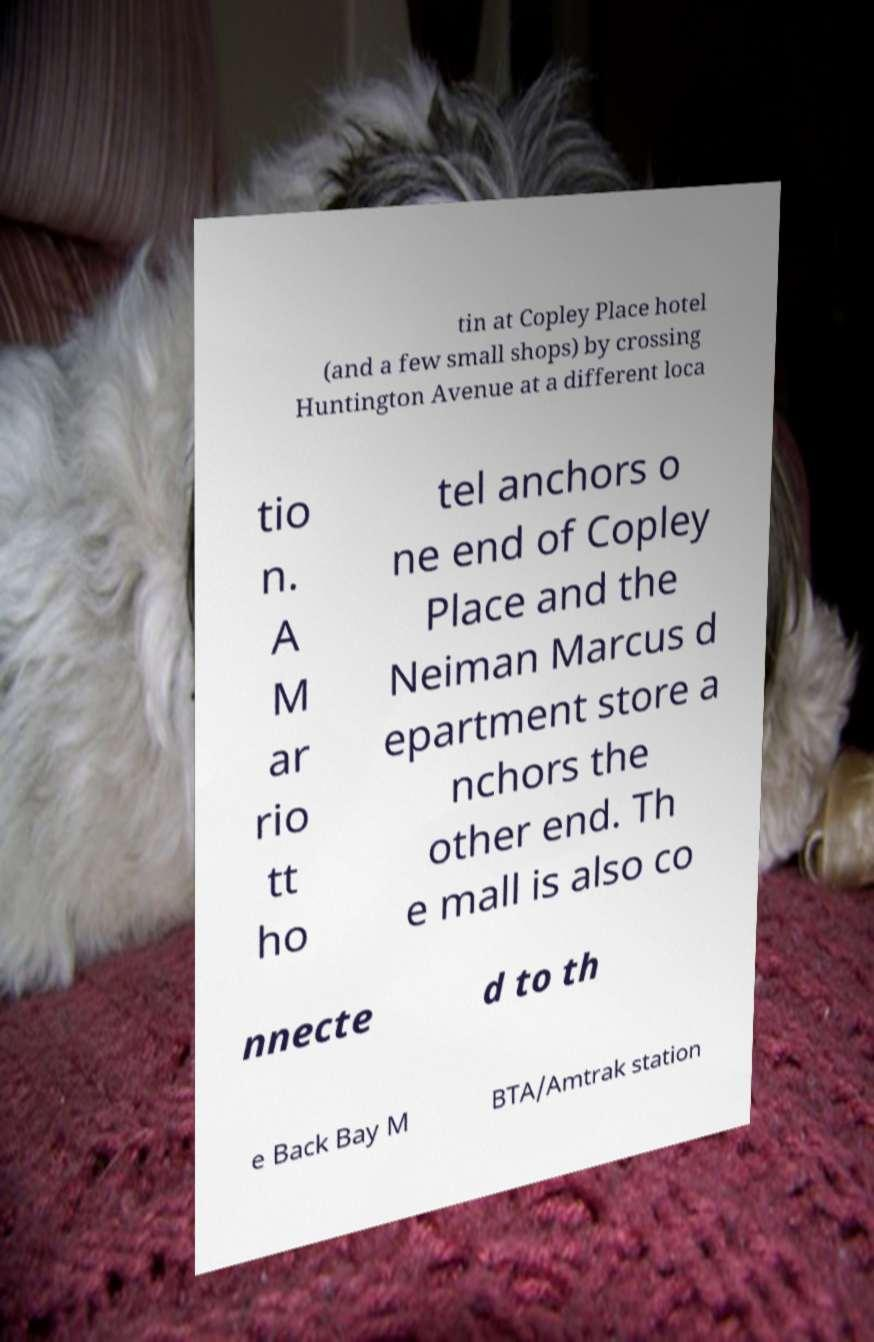What messages or text are displayed in this image? I need them in a readable, typed format. tin at Copley Place hotel (and a few small shops) by crossing Huntington Avenue at a different loca tio n. A M ar rio tt ho tel anchors o ne end of Copley Place and the Neiman Marcus d epartment store a nchors the other end. Th e mall is also co nnecte d to th e Back Bay M BTA/Amtrak station 